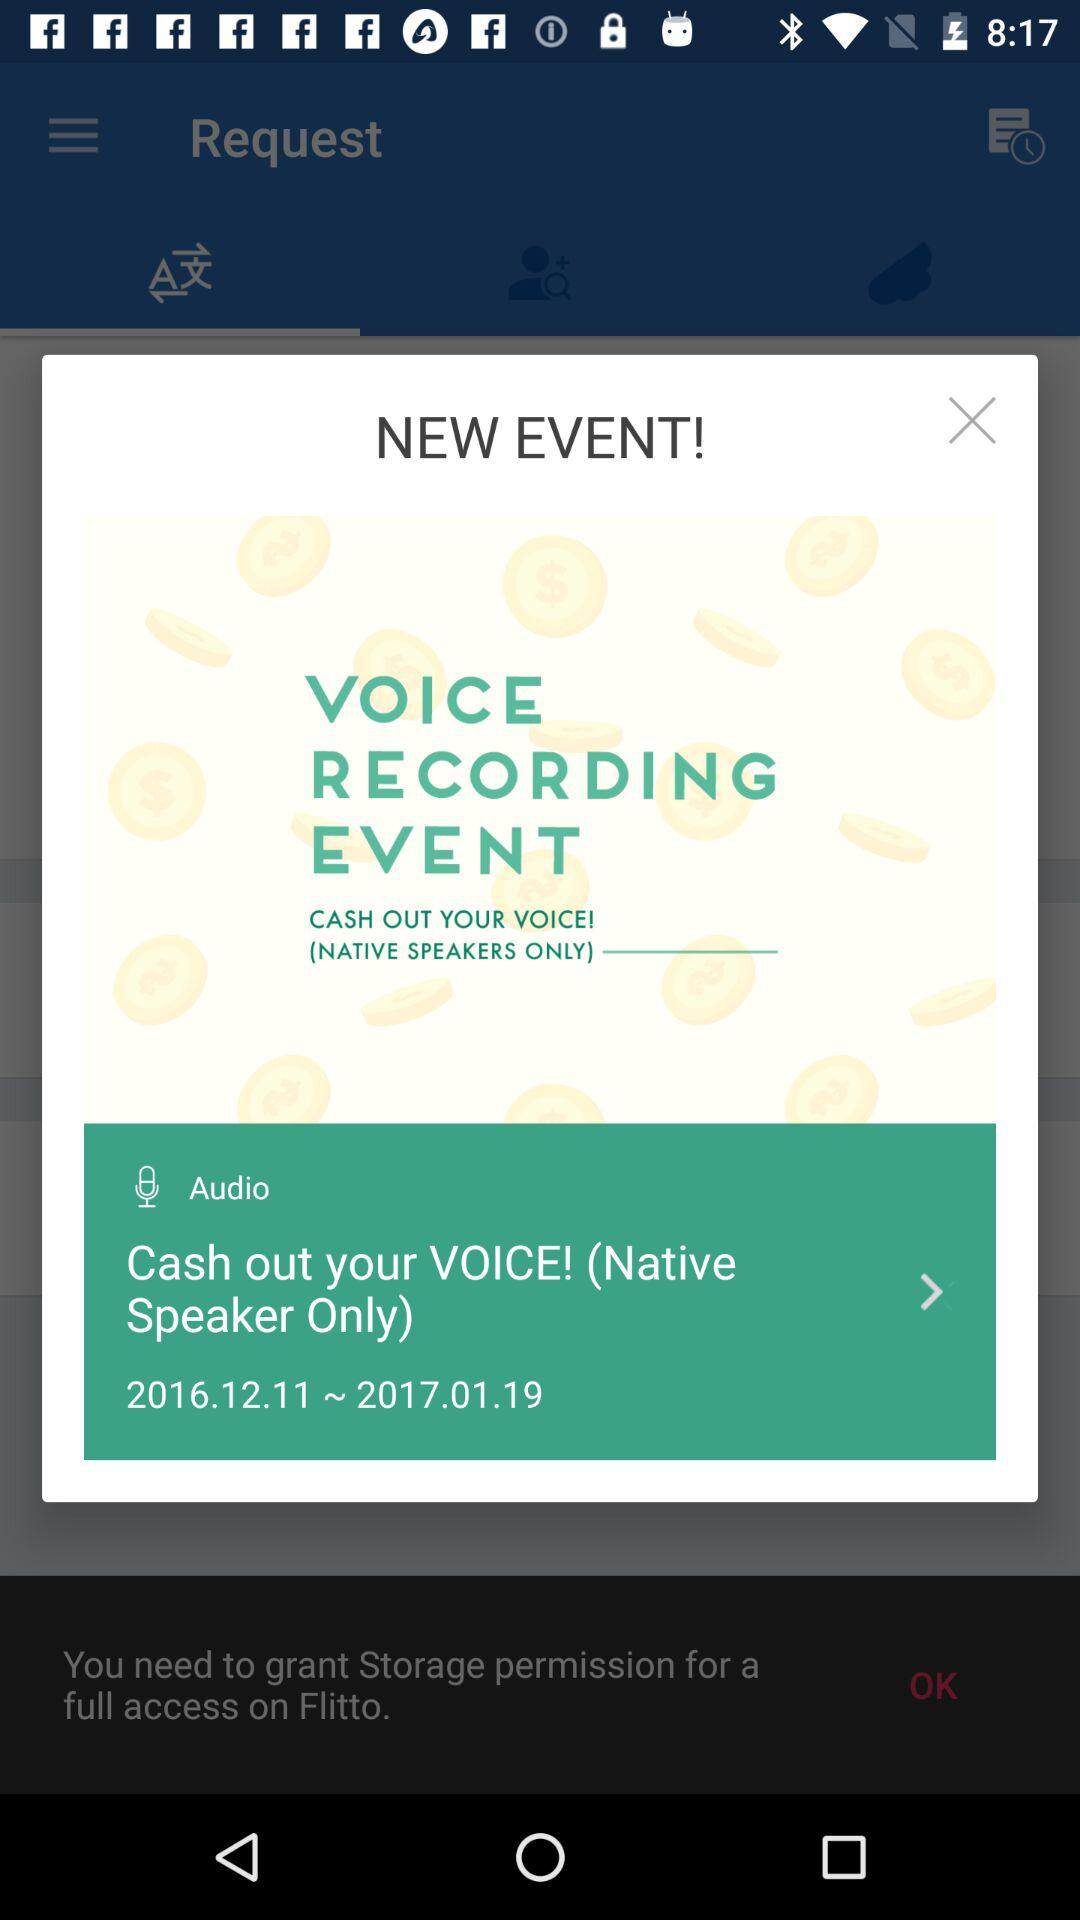What is the date range? The date range is from December 11, 2016 to January 19, 2017. 